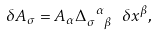<formula> <loc_0><loc_0><loc_500><loc_500>\delta A _ { \sigma } = A _ { \alpha } \Delta _ { \sigma \ \beta } ^ { \ \alpha } \ \delta x ^ { \beta } ,</formula> 